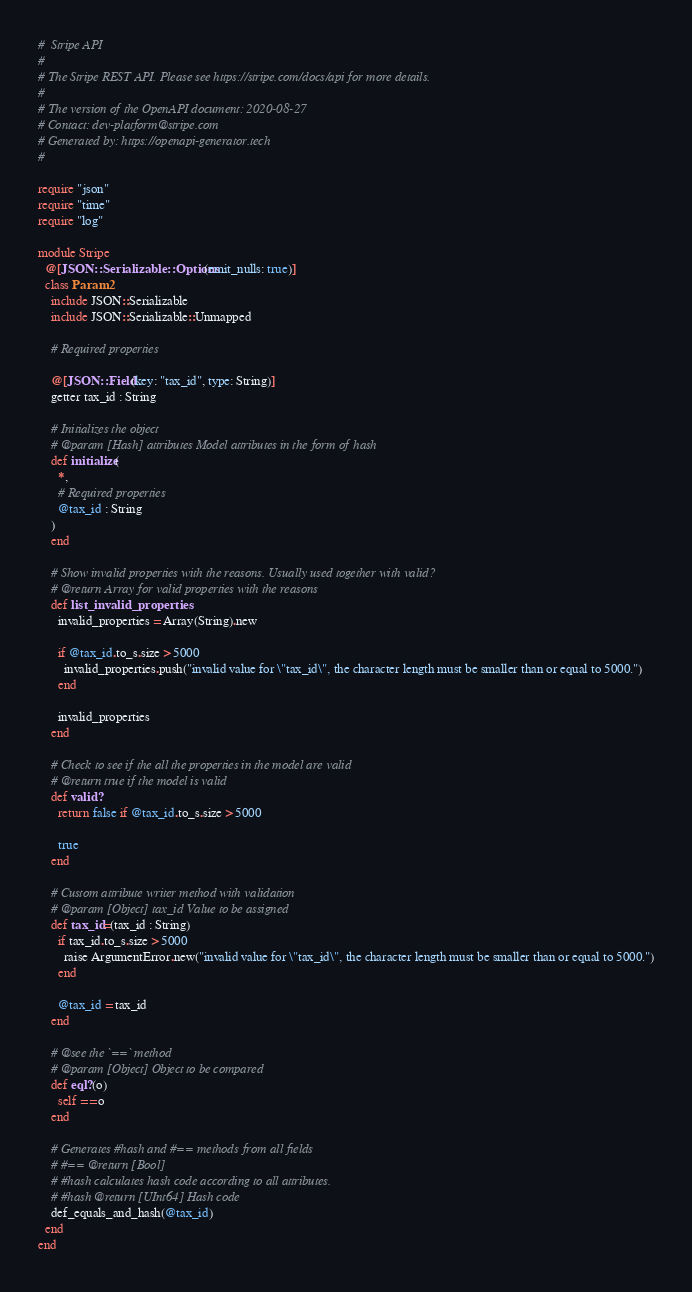<code> <loc_0><loc_0><loc_500><loc_500><_Crystal_>#  Stripe API
#
# The Stripe REST API. Please see https://stripe.com/docs/api for more details.
#
# The version of the OpenAPI document: 2020-08-27
# Contact: dev-platform@stripe.com
# Generated by: https://openapi-generator.tech
#

require "json"
require "time"
require "log"

module Stripe
  @[JSON::Serializable::Options(emit_nulls: true)]
  class Param2
    include JSON::Serializable
    include JSON::Serializable::Unmapped

    # Required properties

    @[JSON::Field(key: "tax_id", type: String)]
    getter tax_id : String

    # Initializes the object
    # @param [Hash] attributes Model attributes in the form of hash
    def initialize(
      *,
      # Required properties
      @tax_id : String
    )
    end

    # Show invalid properties with the reasons. Usually used together with valid?
    # @return Array for valid properties with the reasons
    def list_invalid_properties
      invalid_properties = Array(String).new

      if @tax_id.to_s.size > 5000
        invalid_properties.push("invalid value for \"tax_id\", the character length must be smaller than or equal to 5000.")
      end

      invalid_properties
    end

    # Check to see if the all the properties in the model are valid
    # @return true if the model is valid
    def valid?
      return false if @tax_id.to_s.size > 5000

      true
    end

    # Custom attribute writer method with validation
    # @param [Object] tax_id Value to be assigned
    def tax_id=(tax_id : String)
      if tax_id.to_s.size > 5000
        raise ArgumentError.new("invalid value for \"tax_id\", the character length must be smaller than or equal to 5000.")
      end

      @tax_id = tax_id
    end

    # @see the `==` method
    # @param [Object] Object to be compared
    def eql?(o)
      self == o
    end

    # Generates #hash and #== methods from all fields
    # #== @return [Bool]
    # #hash calculates hash code according to all attributes.
    # #hash @return [UInt64] Hash code
    def_equals_and_hash(@tax_id)
  end
end
</code> 